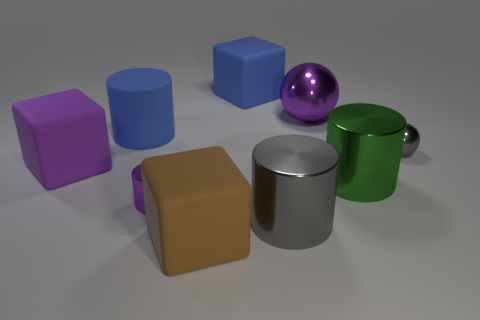Subtract all big blue cylinders. How many cylinders are left? 3 Subtract all gray cylinders. How many cylinders are left? 3 Subtract all red cylinders. Subtract all purple blocks. How many cylinders are left? 4 Subtract all cylinders. How many objects are left? 5 Add 1 small shiny cylinders. How many objects exist? 10 Subtract all purple matte cubes. Subtract all big brown blocks. How many objects are left? 7 Add 3 green cylinders. How many green cylinders are left? 4 Add 8 blue matte objects. How many blue matte objects exist? 10 Subtract 1 blue cylinders. How many objects are left? 8 